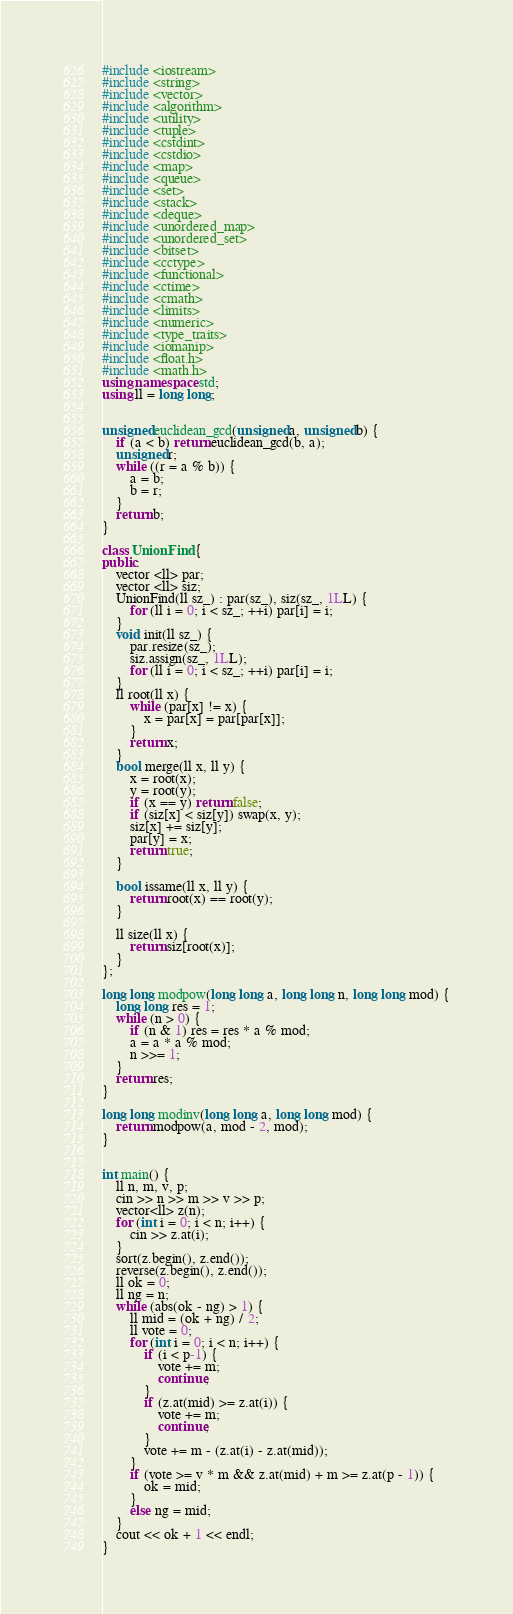Convert code to text. <code><loc_0><loc_0><loc_500><loc_500><_C++_>#include <iostream>
#include <string>
#include <vector>
#include <algorithm>
#include <utility>
#include <tuple>
#include <cstdint>
#include <cstdio>
#include <map>
#include <queue>
#include <set>
#include <stack>
#include <deque>
#include <unordered_map>
#include <unordered_set>
#include <bitset>
#include <cctype>
#include <functional>
#include <ctime>
#include <cmath>
#include <limits>
#include <numeric>
#include <type_traits>
#include <iomanip>
#include <float.h>
#include <math.h>
using namespace std;
using ll = long long;


unsigned euclidean_gcd(unsigned a, unsigned b) {
    if (a < b) return euclidean_gcd(b, a);
    unsigned r;
    while ((r = a % b)) {
        a = b;
        b = r;
    }
    return b;
}

class UnionFind {
public:
    vector <ll> par;
    vector <ll> siz;
    UnionFind(ll sz_) : par(sz_), siz(sz_, 1LL) {
        for (ll i = 0; i < sz_; ++i) par[i] = i;
    }
    void init(ll sz_) {
        par.resize(sz_);
        siz.assign(sz_, 1LL);
        for (ll i = 0; i < sz_; ++i) par[i] = i;
    }
    ll root(ll x) {
        while (par[x] != x) {
            x = par[x] = par[par[x]];
        }
        return x;
    }
    bool merge(ll x, ll y) {
        x = root(x);
        y = root(y);
        if (x == y) return false;
        if (siz[x] < siz[y]) swap(x, y);
        siz[x] += siz[y];
        par[y] = x;
        return true;
    }

    bool issame(ll x, ll y) {
        return root(x) == root(y);
    }

    ll size(ll x) {
        return siz[root(x)];
    }
};

long long modpow(long long a, long long n, long long mod) {
    long long res = 1;
    while (n > 0) {
        if (n & 1) res = res * a % mod;
        a = a * a % mod;
        n >>= 1;
    }
    return res;
}

long long modinv(long long a, long long mod) {
    return modpow(a, mod - 2, mod);
}


int main() {
    ll n, m, v, p;
    cin >> n >> m >> v >> p;
    vector<ll> z(n);
    for (int i = 0; i < n; i++) {
        cin >> z.at(i);
    }
    sort(z.begin(), z.end());
    reverse(z.begin(), z.end());
    ll ok = 0;
    ll ng = n;
    while (abs(ok - ng) > 1) {
        ll mid = (ok + ng) / 2;
        ll vote = 0;
        for (int i = 0; i < n; i++) {
            if (i < p-1) {
                vote += m;
                continue;
            }
            if (z.at(mid) >= z.at(i)) {
                vote += m;
                continue;
            }
            vote += m - (z.at(i) - z.at(mid));
        }
        if (vote >= v * m && z.at(mid) + m >= z.at(p - 1)) {
            ok = mid;
        }
        else ng = mid;
    }
    cout << ok + 1 << endl;
}</code> 